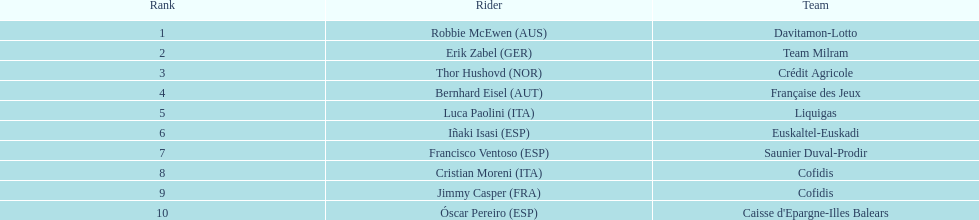How many additional points did erik zabel achieve compared to francisco ventoso? 71. 